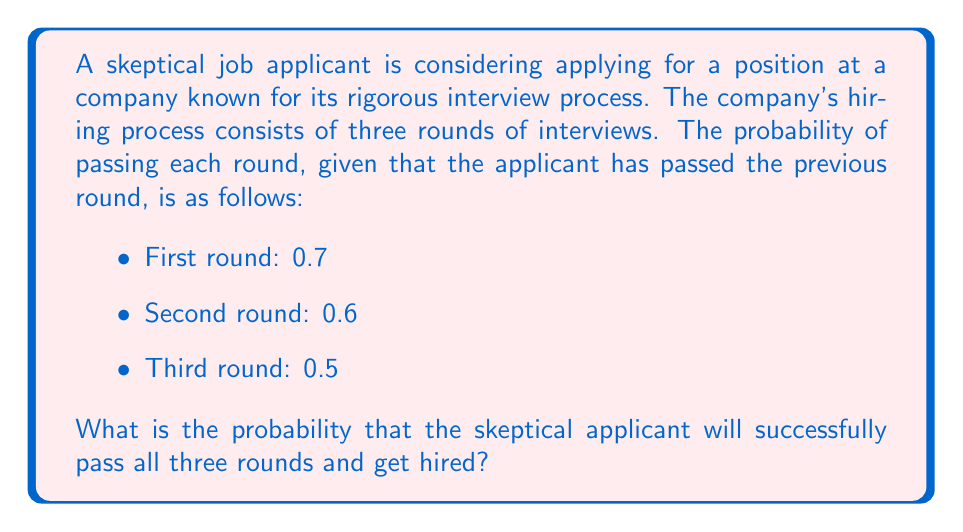Teach me how to tackle this problem. To solve this problem, we need to use the concept of conditional probability and the multiplication rule for independent events.

Let's break down the problem step by step:

1. Define the events:
   Let $A$ = passing the first round
   Let $B$ = passing the second round, given that the first round was passed
   Let $C$ = passing the third round, given that the first two rounds were passed

2. Given probabilities:
   $P(A) = 0.7$
   $P(B|A) = 0.6$
   $P(C|A \cap B) = 0.5$

3. We need to find the probability of passing all three rounds, which can be expressed as:
   $P(A \cap B \cap C)$

4. Using the multiplication rule for conditional probabilities:
   $P(A \cap B \cap C) = P(A) \cdot P(B|A) \cdot P(C|A \cap B)$

5. Substituting the given probabilities:
   $P(A \cap B \cap C) = 0.7 \cdot 0.6 \cdot 0.5$

6. Calculate the final probability:
   $P(A \cap B \cap C) = 0.7 \cdot 0.6 \cdot 0.5 = 0.21$

Therefore, the probability that the skeptical applicant will successfully pass all three rounds and get hired is 0.21 or 21%.
Answer: 0.21 or 21% 